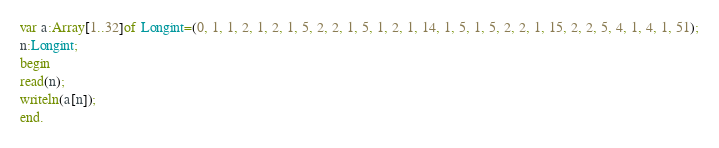<code> <loc_0><loc_0><loc_500><loc_500><_Pascal_>var a:Array[1..32]of Longint=(0, 1, 1, 2, 1, 2, 1, 5, 2, 2, 1, 5, 1, 2, 1, 14, 1, 5, 1, 5, 2, 2, 1, 15, 2, 2, 5, 4, 1, 4, 1, 51);
n:Longint;
begin
read(n);
writeln(a[n]);
end.
</code> 